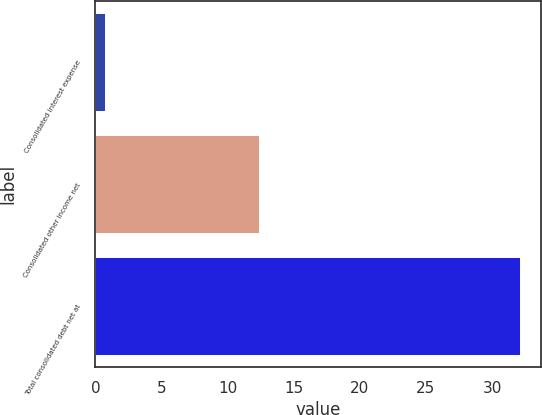<chart> <loc_0><loc_0><loc_500><loc_500><bar_chart><fcel>Consolidated interest expense<fcel>Consolidated other income net<fcel>Total consolidated debt net at<nl><fcel>0.7<fcel>12.4<fcel>32.1<nl></chart> 